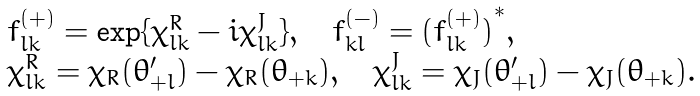<formula> <loc_0><loc_0><loc_500><loc_500>\begin{array} { l } { { f _ { l k } ^ { ( + ) } = \exp \{ \chi _ { l k } ^ { R } - i \chi _ { l k } ^ { J } \} , \quad f _ { k l } ^ { ( - ) } = { ( f _ { l k } ^ { ( + ) } ) } ^ { * } , } } \\ { { \chi _ { l k } ^ { R } = \chi _ { R } ( \theta _ { + l } ^ { \prime } ) - \chi _ { R } ( \theta _ { + k } ) , \quad \chi _ { l k } ^ { J } = \chi _ { J } ( \theta _ { + l } ^ { \prime } ) - \chi _ { J } ( \theta _ { + k } ) . } } \end{array}</formula> 